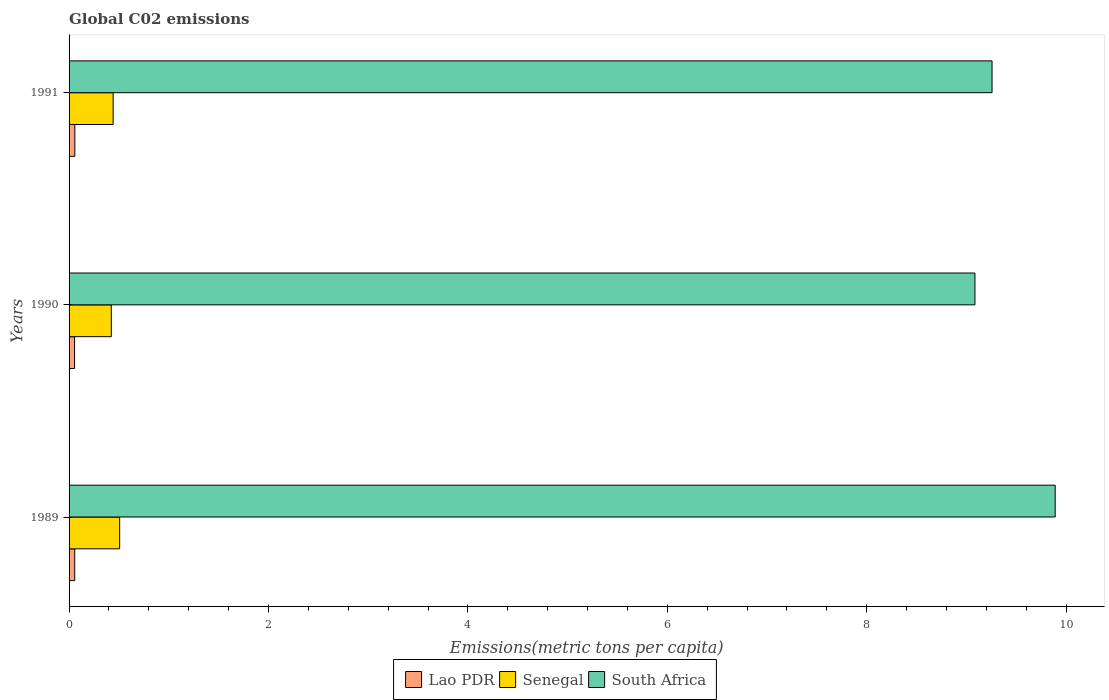How many groups of bars are there?
Keep it short and to the point. 3. Are the number of bars on each tick of the Y-axis equal?
Ensure brevity in your answer.  Yes. How many bars are there on the 2nd tick from the top?
Keep it short and to the point. 3. What is the label of the 2nd group of bars from the top?
Offer a very short reply. 1990. In how many cases, is the number of bars for a given year not equal to the number of legend labels?
Your answer should be compact. 0. What is the amount of CO2 emitted in in South Africa in 1991?
Offer a terse response. 9.26. Across all years, what is the maximum amount of CO2 emitted in in Senegal?
Give a very brief answer. 0.51. Across all years, what is the minimum amount of CO2 emitted in in Senegal?
Your answer should be very brief. 0.42. In which year was the amount of CO2 emitted in in Lao PDR maximum?
Offer a terse response. 1991. What is the total amount of CO2 emitted in in South Africa in the graph?
Your response must be concise. 28.23. What is the difference between the amount of CO2 emitted in in Lao PDR in 1990 and that in 1991?
Provide a succinct answer. -0. What is the difference between the amount of CO2 emitted in in Senegal in 1990 and the amount of CO2 emitted in in South Africa in 1989?
Provide a short and direct response. -9.47. What is the average amount of CO2 emitted in in South Africa per year?
Provide a succinct answer. 9.41. In the year 1991, what is the difference between the amount of CO2 emitted in in South Africa and amount of CO2 emitted in in Senegal?
Ensure brevity in your answer.  8.81. In how many years, is the amount of CO2 emitted in in Lao PDR greater than 6.4 metric tons per capita?
Your response must be concise. 0. What is the ratio of the amount of CO2 emitted in in South Africa in 1989 to that in 1991?
Keep it short and to the point. 1.07. What is the difference between the highest and the second highest amount of CO2 emitted in in Senegal?
Your answer should be compact. 0.07. What is the difference between the highest and the lowest amount of CO2 emitted in in Lao PDR?
Your answer should be compact. 0. What does the 3rd bar from the top in 1989 represents?
Make the answer very short. Lao PDR. What does the 3rd bar from the bottom in 1991 represents?
Keep it short and to the point. South Africa. How many bars are there?
Offer a very short reply. 9. How many years are there in the graph?
Your answer should be compact. 3. What is the difference between two consecutive major ticks on the X-axis?
Keep it short and to the point. 2. Are the values on the major ticks of X-axis written in scientific E-notation?
Your response must be concise. No. Does the graph contain any zero values?
Ensure brevity in your answer.  No. Where does the legend appear in the graph?
Your response must be concise. Bottom center. How many legend labels are there?
Ensure brevity in your answer.  3. How are the legend labels stacked?
Keep it short and to the point. Horizontal. What is the title of the graph?
Your response must be concise. Global C02 emissions. What is the label or title of the X-axis?
Your answer should be compact. Emissions(metric tons per capita). What is the Emissions(metric tons per capita) in Lao PDR in 1989?
Ensure brevity in your answer.  0.06. What is the Emissions(metric tons per capita) in Senegal in 1989?
Keep it short and to the point. 0.51. What is the Emissions(metric tons per capita) of South Africa in 1989?
Give a very brief answer. 9.89. What is the Emissions(metric tons per capita) of Lao PDR in 1990?
Offer a very short reply. 0.06. What is the Emissions(metric tons per capita) in Senegal in 1990?
Your response must be concise. 0.42. What is the Emissions(metric tons per capita) in South Africa in 1990?
Your answer should be compact. 9.09. What is the Emissions(metric tons per capita) of Lao PDR in 1991?
Provide a succinct answer. 0.06. What is the Emissions(metric tons per capita) in Senegal in 1991?
Give a very brief answer. 0.44. What is the Emissions(metric tons per capita) in South Africa in 1991?
Your answer should be compact. 9.26. Across all years, what is the maximum Emissions(metric tons per capita) of Lao PDR?
Make the answer very short. 0.06. Across all years, what is the maximum Emissions(metric tons per capita) in Senegal?
Your response must be concise. 0.51. Across all years, what is the maximum Emissions(metric tons per capita) in South Africa?
Keep it short and to the point. 9.89. Across all years, what is the minimum Emissions(metric tons per capita) in Lao PDR?
Your response must be concise. 0.06. Across all years, what is the minimum Emissions(metric tons per capita) of Senegal?
Offer a terse response. 0.42. Across all years, what is the minimum Emissions(metric tons per capita) in South Africa?
Provide a short and direct response. 9.09. What is the total Emissions(metric tons per capita) of Lao PDR in the graph?
Give a very brief answer. 0.17. What is the total Emissions(metric tons per capita) of Senegal in the graph?
Keep it short and to the point. 1.37. What is the total Emissions(metric tons per capita) in South Africa in the graph?
Provide a succinct answer. 28.23. What is the difference between the Emissions(metric tons per capita) of Lao PDR in 1989 and that in 1990?
Offer a very short reply. 0. What is the difference between the Emissions(metric tons per capita) of Senegal in 1989 and that in 1990?
Make the answer very short. 0.08. What is the difference between the Emissions(metric tons per capita) in South Africa in 1989 and that in 1990?
Offer a very short reply. 0.8. What is the difference between the Emissions(metric tons per capita) of Lao PDR in 1989 and that in 1991?
Make the answer very short. -0. What is the difference between the Emissions(metric tons per capita) of Senegal in 1989 and that in 1991?
Your answer should be compact. 0.07. What is the difference between the Emissions(metric tons per capita) in South Africa in 1989 and that in 1991?
Your answer should be compact. 0.63. What is the difference between the Emissions(metric tons per capita) in Lao PDR in 1990 and that in 1991?
Make the answer very short. -0. What is the difference between the Emissions(metric tons per capita) of Senegal in 1990 and that in 1991?
Provide a succinct answer. -0.02. What is the difference between the Emissions(metric tons per capita) in South Africa in 1990 and that in 1991?
Your answer should be very brief. -0.17. What is the difference between the Emissions(metric tons per capita) of Lao PDR in 1989 and the Emissions(metric tons per capita) of Senegal in 1990?
Provide a succinct answer. -0.37. What is the difference between the Emissions(metric tons per capita) of Lao PDR in 1989 and the Emissions(metric tons per capita) of South Africa in 1990?
Provide a short and direct response. -9.03. What is the difference between the Emissions(metric tons per capita) in Senegal in 1989 and the Emissions(metric tons per capita) in South Africa in 1990?
Your answer should be very brief. -8.58. What is the difference between the Emissions(metric tons per capita) of Lao PDR in 1989 and the Emissions(metric tons per capita) of Senegal in 1991?
Your answer should be very brief. -0.39. What is the difference between the Emissions(metric tons per capita) in Lao PDR in 1989 and the Emissions(metric tons per capita) in South Africa in 1991?
Your answer should be very brief. -9.2. What is the difference between the Emissions(metric tons per capita) of Senegal in 1989 and the Emissions(metric tons per capita) of South Africa in 1991?
Your answer should be very brief. -8.75. What is the difference between the Emissions(metric tons per capita) in Lao PDR in 1990 and the Emissions(metric tons per capita) in Senegal in 1991?
Provide a short and direct response. -0.39. What is the difference between the Emissions(metric tons per capita) in Lao PDR in 1990 and the Emissions(metric tons per capita) in South Africa in 1991?
Provide a succinct answer. -9.2. What is the difference between the Emissions(metric tons per capita) in Senegal in 1990 and the Emissions(metric tons per capita) in South Africa in 1991?
Ensure brevity in your answer.  -8.83. What is the average Emissions(metric tons per capita) of Lao PDR per year?
Provide a succinct answer. 0.06. What is the average Emissions(metric tons per capita) in Senegal per year?
Keep it short and to the point. 0.46. What is the average Emissions(metric tons per capita) in South Africa per year?
Offer a very short reply. 9.41. In the year 1989, what is the difference between the Emissions(metric tons per capita) in Lao PDR and Emissions(metric tons per capita) in Senegal?
Offer a very short reply. -0.45. In the year 1989, what is the difference between the Emissions(metric tons per capita) of Lao PDR and Emissions(metric tons per capita) of South Africa?
Provide a succinct answer. -9.83. In the year 1989, what is the difference between the Emissions(metric tons per capita) of Senegal and Emissions(metric tons per capita) of South Africa?
Make the answer very short. -9.38. In the year 1990, what is the difference between the Emissions(metric tons per capita) of Lao PDR and Emissions(metric tons per capita) of Senegal?
Make the answer very short. -0.37. In the year 1990, what is the difference between the Emissions(metric tons per capita) of Lao PDR and Emissions(metric tons per capita) of South Africa?
Your answer should be very brief. -9.03. In the year 1990, what is the difference between the Emissions(metric tons per capita) of Senegal and Emissions(metric tons per capita) of South Africa?
Offer a terse response. -8.66. In the year 1991, what is the difference between the Emissions(metric tons per capita) in Lao PDR and Emissions(metric tons per capita) in Senegal?
Provide a succinct answer. -0.38. In the year 1991, what is the difference between the Emissions(metric tons per capita) in Lao PDR and Emissions(metric tons per capita) in South Africa?
Offer a terse response. -9.2. In the year 1991, what is the difference between the Emissions(metric tons per capita) of Senegal and Emissions(metric tons per capita) of South Africa?
Your answer should be very brief. -8.81. What is the ratio of the Emissions(metric tons per capita) in Lao PDR in 1989 to that in 1990?
Your response must be concise. 1.03. What is the ratio of the Emissions(metric tons per capita) of Senegal in 1989 to that in 1990?
Keep it short and to the point. 1.2. What is the ratio of the Emissions(metric tons per capita) of South Africa in 1989 to that in 1990?
Provide a short and direct response. 1.09. What is the ratio of the Emissions(metric tons per capita) in Lao PDR in 1989 to that in 1991?
Ensure brevity in your answer.  0.98. What is the ratio of the Emissions(metric tons per capita) of Senegal in 1989 to that in 1991?
Make the answer very short. 1.15. What is the ratio of the Emissions(metric tons per capita) in South Africa in 1989 to that in 1991?
Ensure brevity in your answer.  1.07. What is the ratio of the Emissions(metric tons per capita) of Lao PDR in 1990 to that in 1991?
Offer a very short reply. 0.95. What is the ratio of the Emissions(metric tons per capita) of Senegal in 1990 to that in 1991?
Make the answer very short. 0.96. What is the ratio of the Emissions(metric tons per capita) of South Africa in 1990 to that in 1991?
Your response must be concise. 0.98. What is the difference between the highest and the second highest Emissions(metric tons per capita) of Senegal?
Offer a very short reply. 0.07. What is the difference between the highest and the second highest Emissions(metric tons per capita) of South Africa?
Offer a very short reply. 0.63. What is the difference between the highest and the lowest Emissions(metric tons per capita) of Lao PDR?
Make the answer very short. 0. What is the difference between the highest and the lowest Emissions(metric tons per capita) in Senegal?
Keep it short and to the point. 0.08. What is the difference between the highest and the lowest Emissions(metric tons per capita) of South Africa?
Your answer should be very brief. 0.8. 